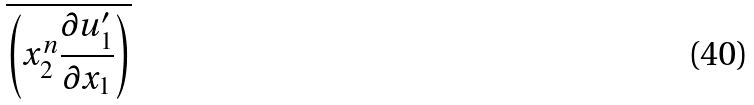<formula> <loc_0><loc_0><loc_500><loc_500>\overline { \left ( { x _ { 2 } ^ { n } \frac { \partial u ^ { \prime } _ { 1 } } { \partial x _ { 1 } } } \right ) }</formula> 